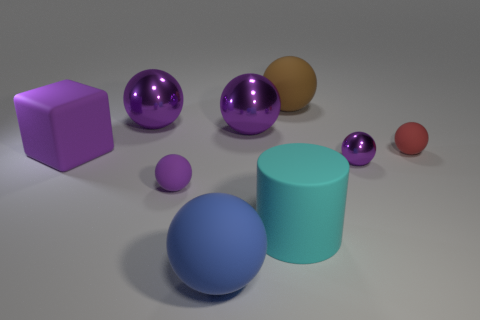How do the objects in the image relate to each other in terms of size? The objects in the image show a variety of sizes which appear to be carefully arranged to demonstrate scale. The largest objects are the purple sphere and the cyan cylinder, while the smallest ones seem to be the tiny purple sphere and the small red sphere. This arrangement allows us to visualize and compare their relative sizes in a three-dimensional space. 